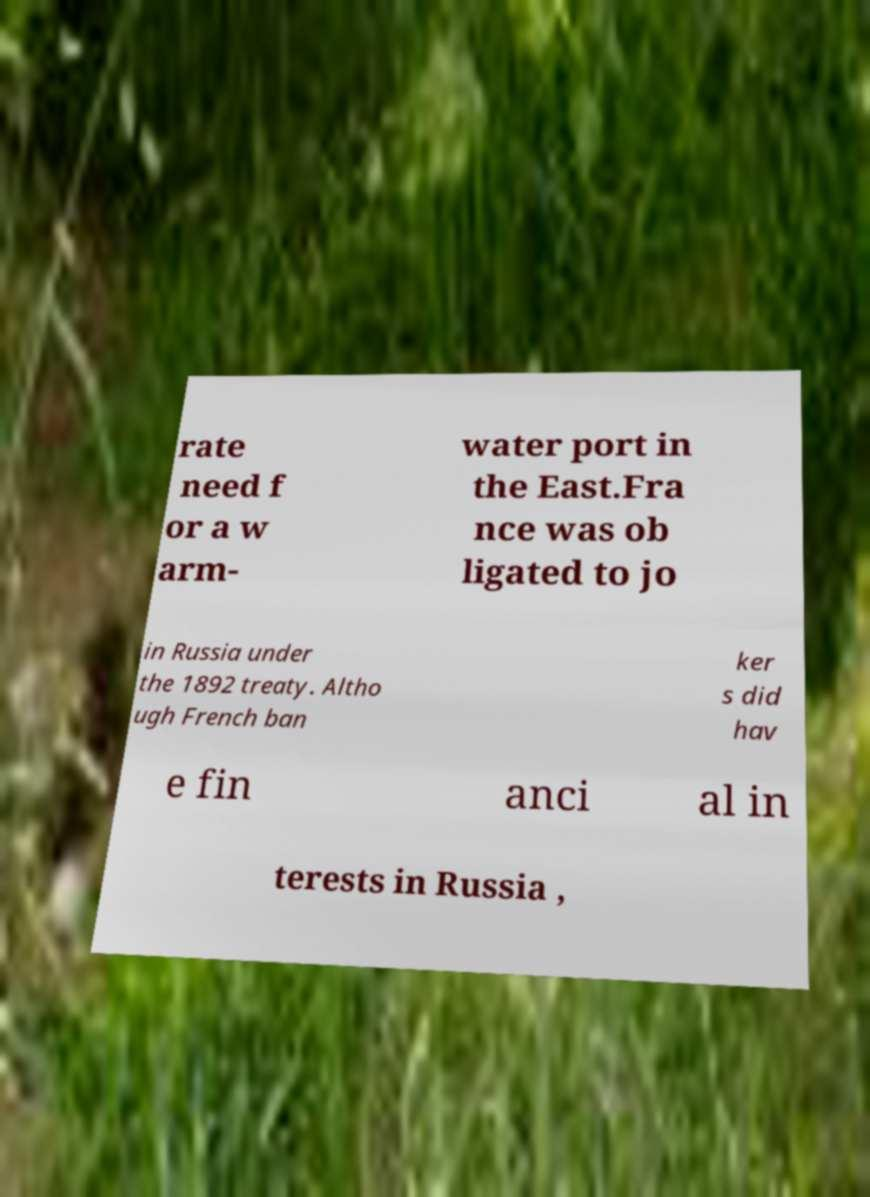For documentation purposes, I need the text within this image transcribed. Could you provide that? rate need f or a w arm- water port in the East.Fra nce was ob ligated to jo in Russia under the 1892 treaty. Altho ugh French ban ker s did hav e fin anci al in terests in Russia , 